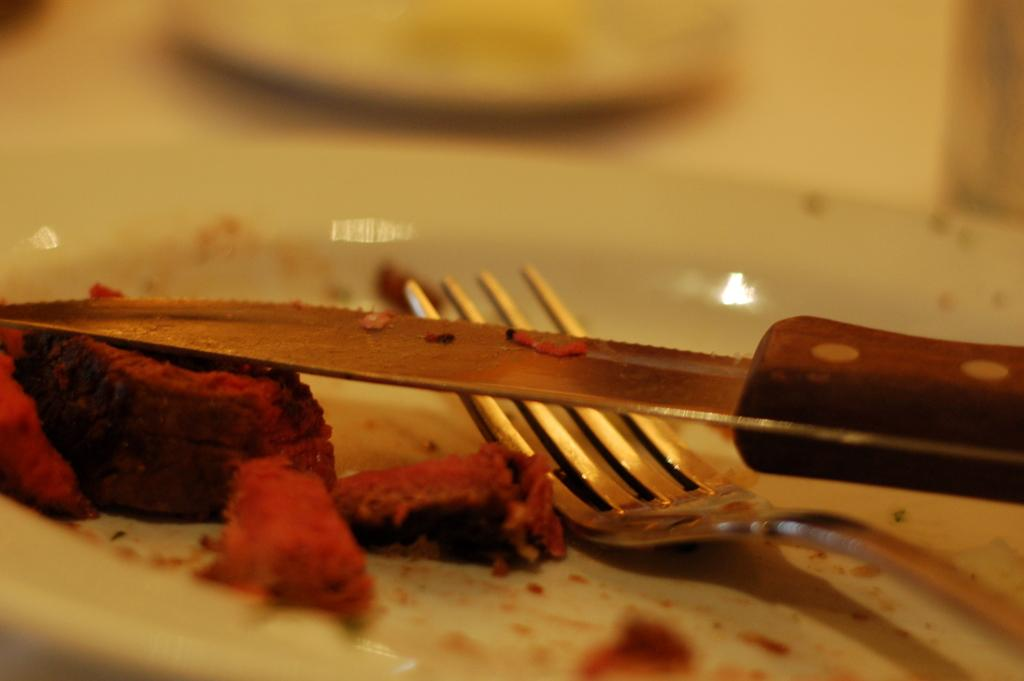What type of food item is in the image? The food item in the image is in a white color palette. What utensils are present on the plate with the food item? There is a knife and a fork on the plate. Where is the insect located on the plate in the image? There is no insect present on the plate in the image. What type of toad can be seen sitting on the food item in the image? There is no toad present on the food item in the image. 